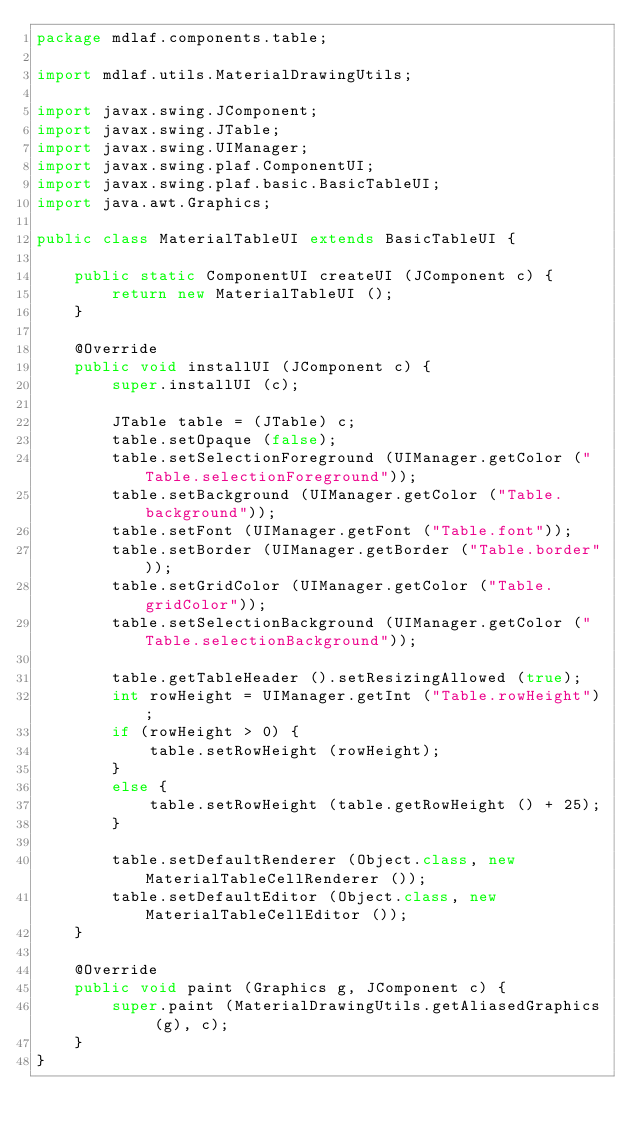Convert code to text. <code><loc_0><loc_0><loc_500><loc_500><_Java_>package mdlaf.components.table;

import mdlaf.utils.MaterialDrawingUtils;

import javax.swing.JComponent;
import javax.swing.JTable;
import javax.swing.UIManager;
import javax.swing.plaf.ComponentUI;
import javax.swing.plaf.basic.BasicTableUI;
import java.awt.Graphics;

public class MaterialTableUI extends BasicTableUI {

	public static ComponentUI createUI (JComponent c) {
		return new MaterialTableUI ();
	}

	@Override
	public void installUI (JComponent c) {
		super.installUI (c);

		JTable table = (JTable) c;
		table.setOpaque (false);
		table.setSelectionForeground (UIManager.getColor ("Table.selectionForeground"));
		table.setBackground (UIManager.getColor ("Table.background"));
		table.setFont (UIManager.getFont ("Table.font"));
		table.setBorder (UIManager.getBorder ("Table.border"));
		table.setGridColor (UIManager.getColor ("Table.gridColor"));
		table.setSelectionBackground (UIManager.getColor ("Table.selectionBackground"));

		table.getTableHeader ().setResizingAllowed (true);
		int rowHeight = UIManager.getInt ("Table.rowHeight");
		if (rowHeight > 0) {
			table.setRowHeight (rowHeight);
		}
		else {
			table.setRowHeight (table.getRowHeight () + 25);
		}

		table.setDefaultRenderer (Object.class, new MaterialTableCellRenderer ());
		table.setDefaultEditor (Object.class, new MaterialTableCellEditor ());
	}

	@Override
	public void paint (Graphics g, JComponent c) {
		super.paint (MaterialDrawingUtils.getAliasedGraphics (g), c);
	}
}
</code> 